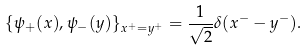<formula> <loc_0><loc_0><loc_500><loc_500>\{ \psi _ { + } ( x ) , \psi _ { - } ( y ) \} _ { x ^ { + } = y ^ { + } } = \frac { 1 } { \sqrt { 2 } } \delta ( x ^ { - } - y ^ { - } ) .</formula> 